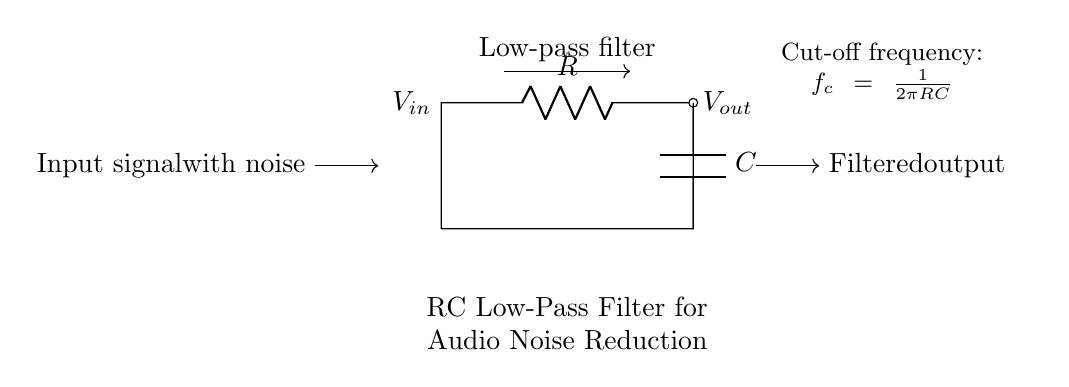What type of circuit is shown? The circuit is an RC low-pass filter, identifiable by the resistor and capacitor in sequence, which allows low-frequency signals to pass through while attenuating higher frequencies.
Answer: RC low-pass filter What are the two main components in the circuit? The main components in the circuit are a resistor and a capacitor. The schematic clearly shows a labeled resistor (R) and capacitor (C) connected together in a specific configuration.
Answer: Resistor and capacitor What is the input signal labeled as? The input signal is labeled as "Vin" in the circuit diagram, indicating where the incoming signal with noise is applied to the filter.
Answer: Vin What does the output label indicate? The output label indicates "Vout," which represents the filtered output signal after passing through the RC low-pass filter. It is the signal derived after processing the input.
Answer: Vout What is the formula provided for cut-off frequency? The formula for cut-off frequency, displayed in the circuit, is "fc = 1/(2πRC)," indicating how the cut-off frequency depends on the values of the resistor and capacitor.
Answer: fc = 1/(2πRC) How does this circuit reduce noise? The circuit reduces noise by allowing lower frequency components (including the desired audio signals) to pass while filtering out higher frequency noise. This is achieved by the characteristics of the RC combination that attenuates unwanted signals.
Answer: By filtering out higher frequencies What is the function of the arrow labeled "Low-pass filter"? The labeled arrow signifies the overall function of the circuit, indicating that it is designed to act as a low-pass filter, which highlights its purpose in processing the input signal.
Answer: To indicate it is a low-pass filter 